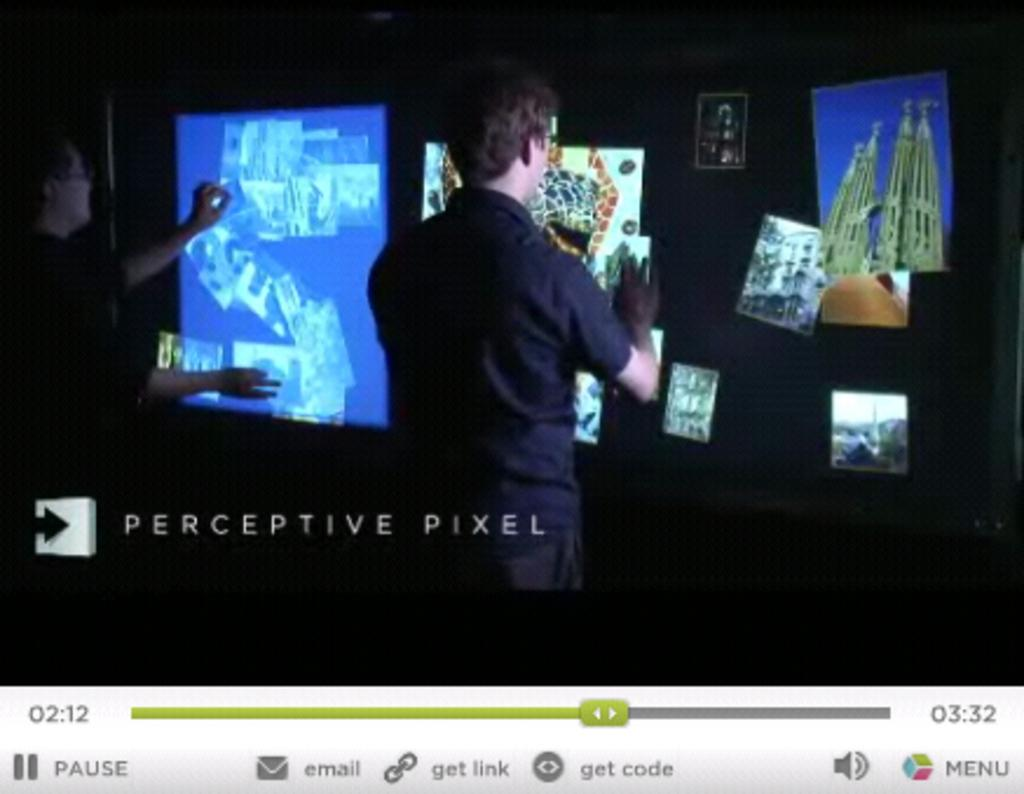<image>
Write a terse but informative summary of the picture. Two men work on a large touch screen by Perceptive Pixel. 